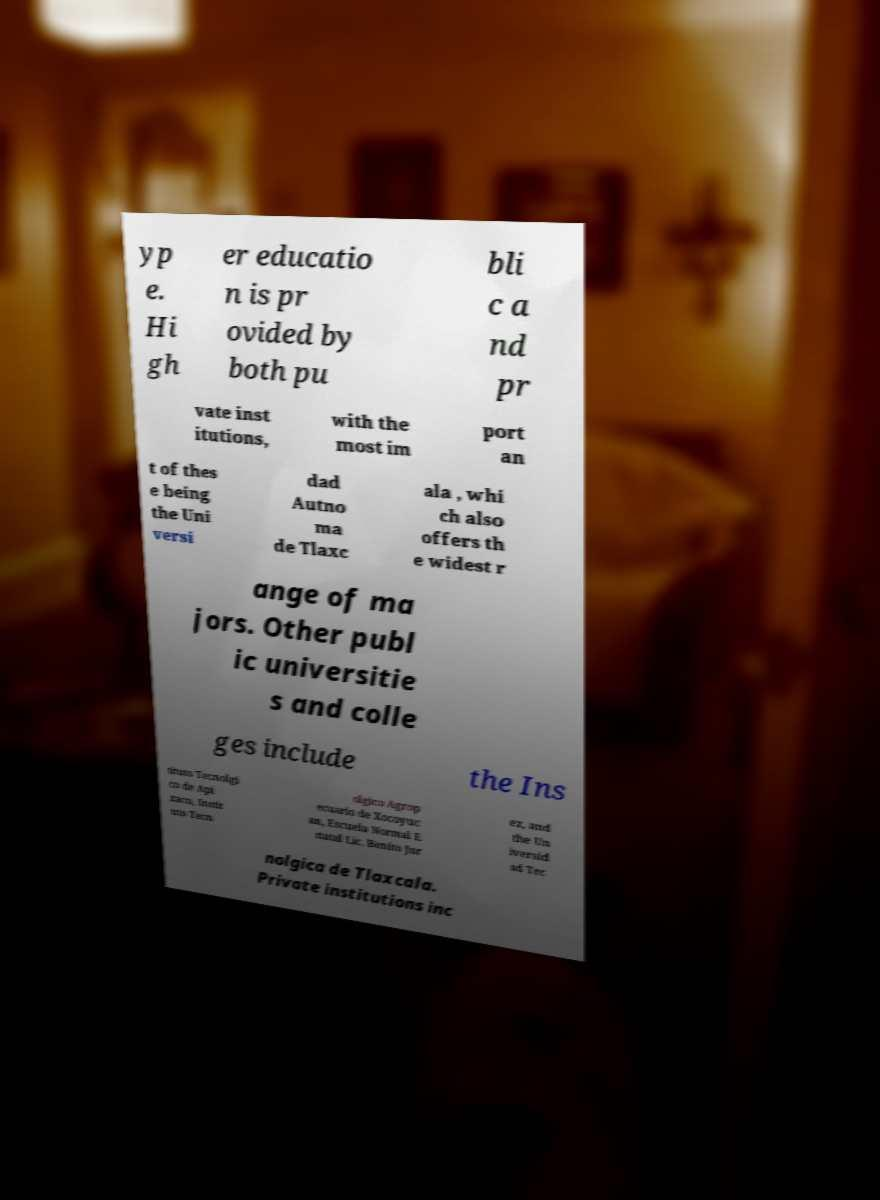Please identify and transcribe the text found in this image. yp e. Hi gh er educatio n is pr ovided by both pu bli c a nd pr vate inst itutions, with the most im port an t of thes e being the Uni versi dad Autno ma de Tlaxc ala , whi ch also offers th e widest r ange of ma jors. Other publ ic universitie s and colle ges include the Ins tituto Tecnolgi co de Api zaco, Instit uto Tecn olgico Agrop ecuario de Xocoyuc an, Escuela Normal E statal Lic. Benito Jur ez, and the Un iversid ad Tec nolgica de Tlaxcala. Private institutions inc 